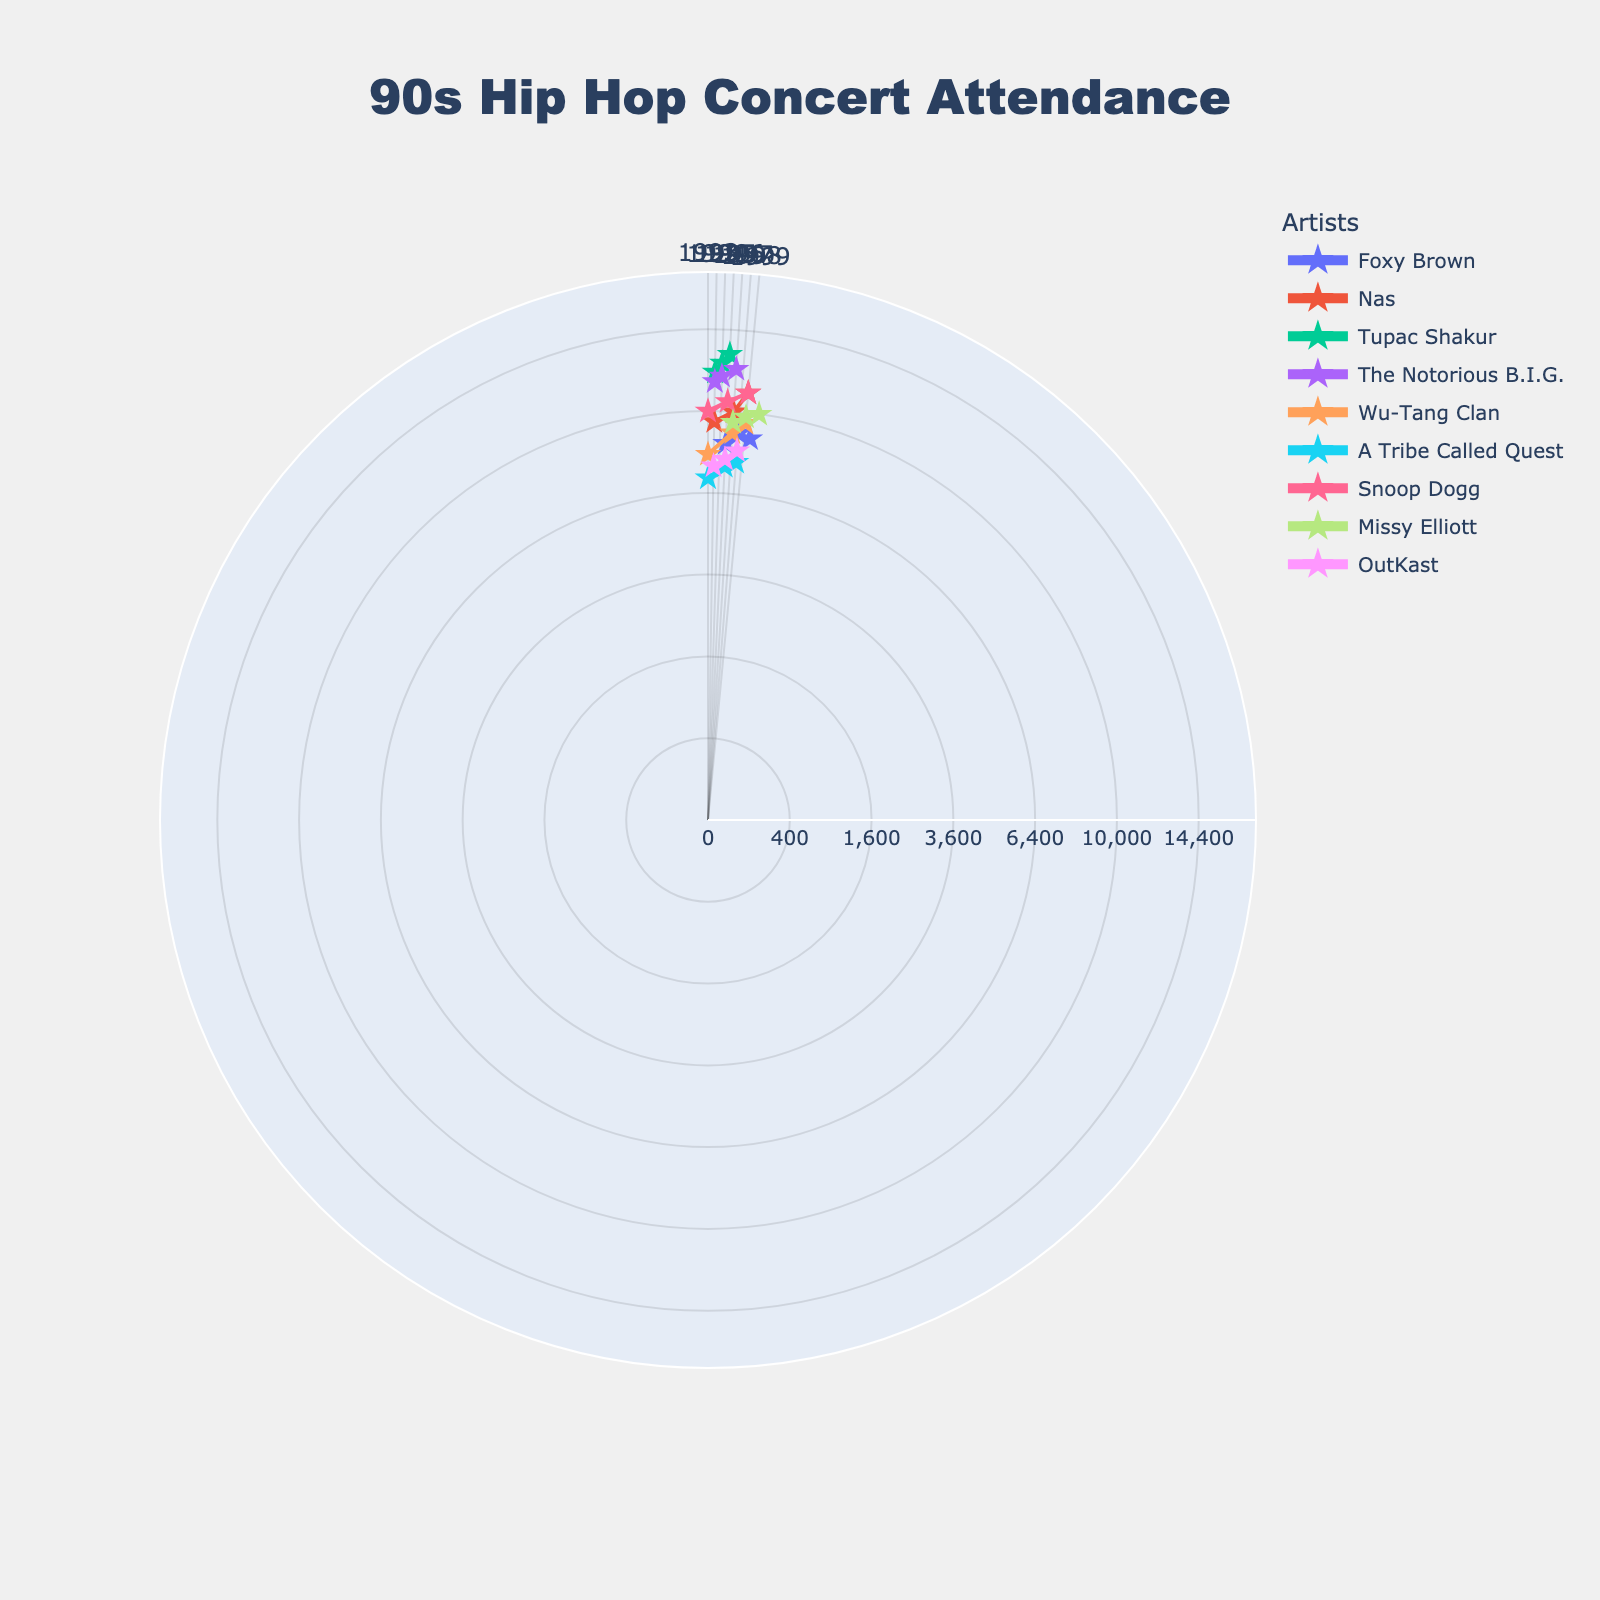Which artist had the highest concert attendance in 1996? Look at the 1996 data points and compare the attendance values for each artist. Tupac Shakur has the highest attendance that year with 13,000 attendees.
Answer: Tupac Shakur How did Foxy Brown's concert attendance change from 1996 to 2000? Compare the attendance values for Foxy Brown in 1996 (8,500), 1998 (9,000), and 2000 (8,800). The attendance increased from 1996 to 1998, then slightly decreased by 2000.
Answer: Increased then decreased Which two artists had the closest attendance numbers in 1999? Compare the 1999 attendance values for all artists: Nas (11,000), Wu-Tang Clan (9,500), Missy Elliott (9,800), and Snoop Dogg (11,000). Nas and Snoop Dogg both had 11,000 attendees, so they had the closest and equal attendance numbers.
Answer: Nas and Snoop Dogg What's the average concert attendance for Tupac Shakur from 1994 to 1996? Tupac Shakur's attendance numbers in 1994, 1995, and 1996 are 12,000, 12,500, and 13,000 respectively. Summing these gives 12,000 + 12,500 + 13,000 = 37,500. The average is 37,500 / 3 = 12,500.
Answer: 12,500 Which artist experienced the largest increase in concert attendance between their first and last recorded years? Calculate the differences between the first and last recorded attendance for each artist:
- Foxy Brown: 8,500 (1996) to 8,800 (2000) = 300
- Nas: 9,500 (1994) to 11,000 (1999) = 1,500
- Tupac Shakur: 12,000 (1994) to 13,000 (1996) = 1,000
- The Notorious B.I.G.: 11,500 (1994) to 12,200 (1997) = 700
- Wu-Tang Clan: 8,000 (1993) to 9,500 (1999) = 1,500
- A Tribe Called Quest: 7,000 (1993) to 7,700 (1998) = 700
- Snoop Dogg: 10,000 (1993) to 11,000 (1999) = 1,000
- Missy Elliott: 9,500 (1997) to 10,000 (2001) = 500
- OutKast: 7,500 (1994) to 8,200 (1998) = 700
Nas and Wu-Tang Clan both have the largest increase of 1,500.
Answer: Nas and Wu-Tang Clan How many artists had an attendance higher than 10,000 in any one year? Review each artist's data to count the number of unique artists who had any attendance value over 10,000. These are: Nas, Tupac Shakur, The Notorious B.I.G., Snoop Dogg, Missy Elliott.
Answer: 5 artists Which artist was more popular in 1997: Missy Elliott or Wu-Tang Clan? Compare their attendance values in 1997: Missy Elliott (9,500) and Wu-Tang Clan (9,000). Missy Elliott had a higher attendance.
Answer: Missy Elliott Did A Tribe Called Quest's concert attendance ever exceed 8,000? Review the attendance values for A Tribe Called Quest in 1993, 1996, and 1998. None of the values (7,000, 7,500, 7,700) exceed 8,000.
Answer: No 